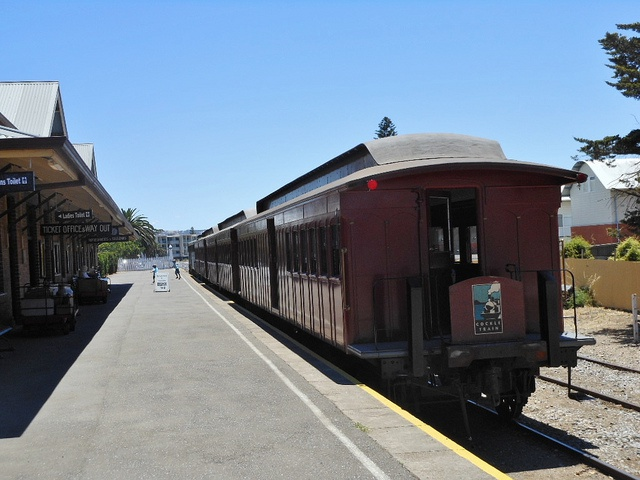Describe the objects in this image and their specific colors. I can see train in lightblue, black, darkgray, and gray tones, people in lightblue, black, darkblue, and gray tones, people in lightblue, gray, darkgray, and black tones, people in lightblue, black, and gray tones, and people in lightblue, darkgray, gray, lightgray, and black tones in this image. 